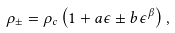Convert formula to latex. <formula><loc_0><loc_0><loc_500><loc_500>\rho _ { \pm } = \rho _ { c } \left ( 1 + a \epsilon \pm b \epsilon ^ { \beta } \right ) ,</formula> 